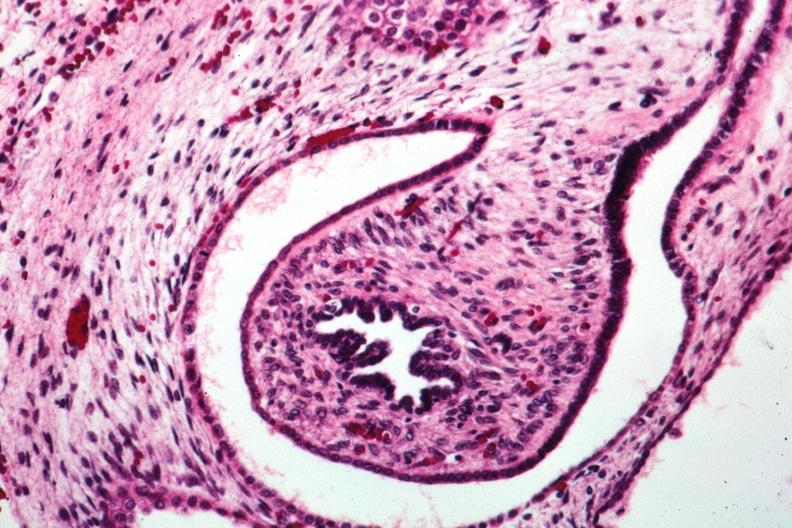s kidney present?
Answer the question using a single word or phrase. Yes 